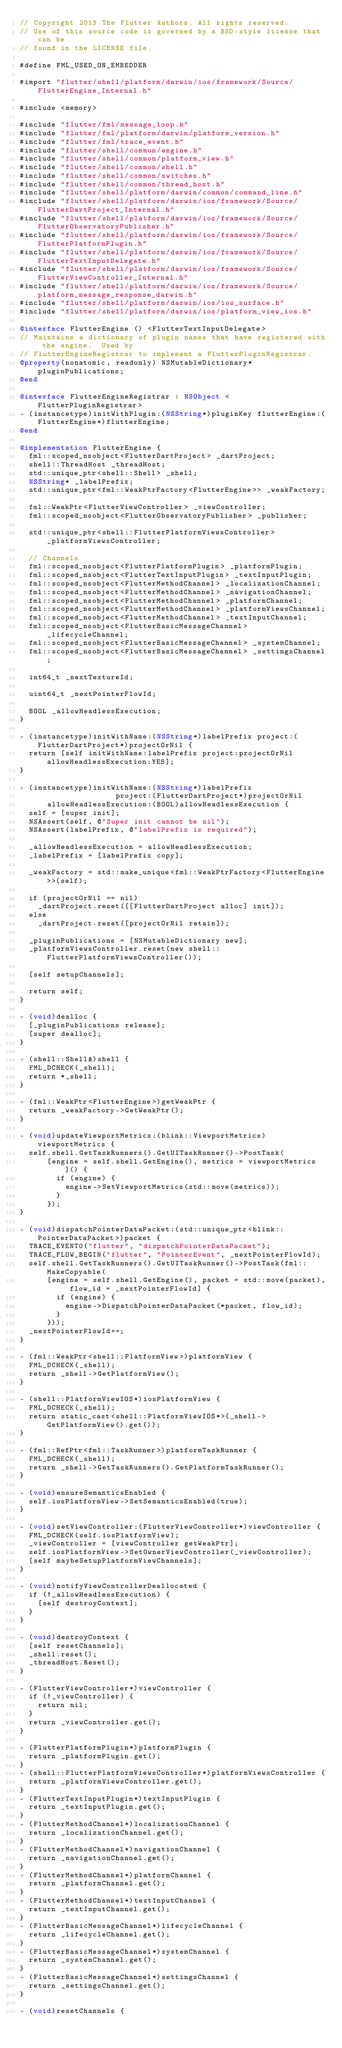<code> <loc_0><loc_0><loc_500><loc_500><_ObjectiveC_>// Copyright 2013 The Flutter Authors. All rights reserved.
// Use of this source code is governed by a BSD-style license that can be
// found in the LICENSE file.

#define FML_USED_ON_EMBEDDER

#import "flutter/shell/platform/darwin/ios/framework/Source/FlutterEngine_Internal.h"

#include <memory>

#include "flutter/fml/message_loop.h"
#include "flutter/fml/platform/darwin/platform_version.h"
#include "flutter/fml/trace_event.h"
#include "flutter/shell/common/engine.h"
#include "flutter/shell/common/platform_view.h"
#include "flutter/shell/common/shell.h"
#include "flutter/shell/common/switches.h"
#include "flutter/shell/common/thread_host.h"
#include "flutter/shell/platform/darwin/common/command_line.h"
#include "flutter/shell/platform/darwin/ios/framework/Source/FlutterDartProject_Internal.h"
#include "flutter/shell/platform/darwin/ios/framework/Source/FlutterObservatoryPublisher.h"
#include "flutter/shell/platform/darwin/ios/framework/Source/FlutterPlatformPlugin.h"
#include "flutter/shell/platform/darwin/ios/framework/Source/FlutterTextInputDelegate.h"
#include "flutter/shell/platform/darwin/ios/framework/Source/FlutterViewController_Internal.h"
#include "flutter/shell/platform/darwin/ios/framework/Source/platform_message_response_darwin.h"
#include "flutter/shell/platform/darwin/ios/ios_surface.h"
#include "flutter/shell/platform/darwin/ios/platform_view_ios.h"

@interface FlutterEngine () <FlutterTextInputDelegate>
// Maintains a dictionary of plugin names that have registered with the engine.  Used by
// FlutterEngineRegistrar to implement a FlutterPluginRegistrar.
@property(nonatomic, readonly) NSMutableDictionary* pluginPublications;
@end

@interface FlutterEngineRegistrar : NSObject <FlutterPluginRegistrar>
- (instancetype)initWithPlugin:(NSString*)pluginKey flutterEngine:(FlutterEngine*)flutterEngine;
@end

@implementation FlutterEngine {
  fml::scoped_nsobject<FlutterDartProject> _dartProject;
  shell::ThreadHost _threadHost;
  std::unique_ptr<shell::Shell> _shell;
  NSString* _labelPrefix;
  std::unique_ptr<fml::WeakPtrFactory<FlutterEngine>> _weakFactory;

  fml::WeakPtr<FlutterViewController> _viewController;
  fml::scoped_nsobject<FlutterObservatoryPublisher> _publisher;

  std::unique_ptr<shell::FlutterPlatformViewsController> _platformViewsController;

  // Channels
  fml::scoped_nsobject<FlutterPlatformPlugin> _platformPlugin;
  fml::scoped_nsobject<FlutterTextInputPlugin> _textInputPlugin;
  fml::scoped_nsobject<FlutterMethodChannel> _localizationChannel;
  fml::scoped_nsobject<FlutterMethodChannel> _navigationChannel;
  fml::scoped_nsobject<FlutterMethodChannel> _platformChannel;
  fml::scoped_nsobject<FlutterMethodChannel> _platformViewsChannel;
  fml::scoped_nsobject<FlutterMethodChannel> _textInputChannel;
  fml::scoped_nsobject<FlutterBasicMessageChannel> _lifecycleChannel;
  fml::scoped_nsobject<FlutterBasicMessageChannel> _systemChannel;
  fml::scoped_nsobject<FlutterBasicMessageChannel> _settingsChannel;

  int64_t _nextTextureId;

  uint64_t _nextPointerFlowId;

  BOOL _allowHeadlessExecution;
}

- (instancetype)initWithName:(NSString*)labelPrefix project:(FlutterDartProject*)projectOrNil {
  return [self initWithName:labelPrefix project:projectOrNil allowHeadlessExecution:YES];
}

- (instancetype)initWithName:(NSString*)labelPrefix
                     project:(FlutterDartProject*)projectOrNil
      allowHeadlessExecution:(BOOL)allowHeadlessExecution {
  self = [super init];
  NSAssert(self, @"Super init cannot be nil");
  NSAssert(labelPrefix, @"labelPrefix is required");

  _allowHeadlessExecution = allowHeadlessExecution;
  _labelPrefix = [labelPrefix copy];

  _weakFactory = std::make_unique<fml::WeakPtrFactory<FlutterEngine>>(self);

  if (projectOrNil == nil)
    _dartProject.reset([[FlutterDartProject alloc] init]);
  else
    _dartProject.reset([projectOrNil retain]);

  _pluginPublications = [NSMutableDictionary new];
  _platformViewsController.reset(new shell::FlutterPlatformViewsController());

  [self setupChannels];

  return self;
}

- (void)dealloc {
  [_pluginPublications release];
  [super dealloc];
}

- (shell::Shell&)shell {
  FML_DCHECK(_shell);
  return *_shell;
}

- (fml::WeakPtr<FlutterEngine>)getWeakPtr {
  return _weakFactory->GetWeakPtr();
}

- (void)updateViewportMetrics:(blink::ViewportMetrics)viewportMetrics {
  self.shell.GetTaskRunners().GetUITaskRunner()->PostTask(
      [engine = self.shell.GetEngine(), metrics = viewportMetrics]() {
        if (engine) {
          engine->SetViewportMetrics(std::move(metrics));
        }
      });
}

- (void)dispatchPointerDataPacket:(std::unique_ptr<blink::PointerDataPacket>)packet {
  TRACE_EVENT0("flutter", "dispatchPointerDataPacket");
  TRACE_FLOW_BEGIN("flutter", "PointerEvent", _nextPointerFlowId);
  self.shell.GetTaskRunners().GetUITaskRunner()->PostTask(fml::MakeCopyable(
      [engine = self.shell.GetEngine(), packet = std::move(packet), flow_id = _nextPointerFlowId] {
        if (engine) {
          engine->DispatchPointerDataPacket(*packet, flow_id);
        }
      }));
  _nextPointerFlowId++;
}

- (fml::WeakPtr<shell::PlatformView>)platformView {
  FML_DCHECK(_shell);
  return _shell->GetPlatformView();
}

- (shell::PlatformViewIOS*)iosPlatformView {
  FML_DCHECK(_shell);
  return static_cast<shell::PlatformViewIOS*>(_shell->GetPlatformView().get());
}

- (fml::RefPtr<fml::TaskRunner>)platformTaskRunner {
  FML_DCHECK(_shell);
  return _shell->GetTaskRunners().GetPlatformTaskRunner();
}

- (void)ensureSemanticsEnabled {
  self.iosPlatformView->SetSemanticsEnabled(true);
}

- (void)setViewController:(FlutterViewController*)viewController {
  FML_DCHECK(self.iosPlatformView);
  _viewController = [viewController getWeakPtr];
  self.iosPlatformView->SetOwnerViewController(_viewController);
  [self maybeSetupPlatformViewChannels];
}

- (void)notifyViewControllerDeallocated {
  if (!_allowHeadlessExecution) {
    [self destroyContext];
  }
}

- (void)destroyContext {
  [self resetChannels];
  _shell.reset();
  _threadHost.Reset();
}

- (FlutterViewController*)viewController {
  if (!_viewController) {
    return nil;
  }
  return _viewController.get();
}

- (FlutterPlatformPlugin*)platformPlugin {
  return _platformPlugin.get();
}
- (shell::FlutterPlatformViewsController*)platformViewsController {
  return _platformViewsController.get();
}
- (FlutterTextInputPlugin*)textInputPlugin {
  return _textInputPlugin.get();
}
- (FlutterMethodChannel*)localizationChannel {
  return _localizationChannel.get();
}
- (FlutterMethodChannel*)navigationChannel {
  return _navigationChannel.get();
}
- (FlutterMethodChannel*)platformChannel {
  return _platformChannel.get();
}
- (FlutterMethodChannel*)textInputChannel {
  return _textInputChannel.get();
}
- (FlutterBasicMessageChannel*)lifecycleChannel {
  return _lifecycleChannel.get();
}
- (FlutterBasicMessageChannel*)systemChannel {
  return _systemChannel.get();
}
- (FlutterBasicMessageChannel*)settingsChannel {
  return _settingsChannel.get();
}

- (void)resetChannels {</code> 